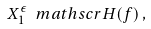Convert formula to latex. <formula><loc_0><loc_0><loc_500><loc_500>X _ { 1 } ^ { \epsilon } \ m a t h s c r { H } ( f ) \, ,</formula> 